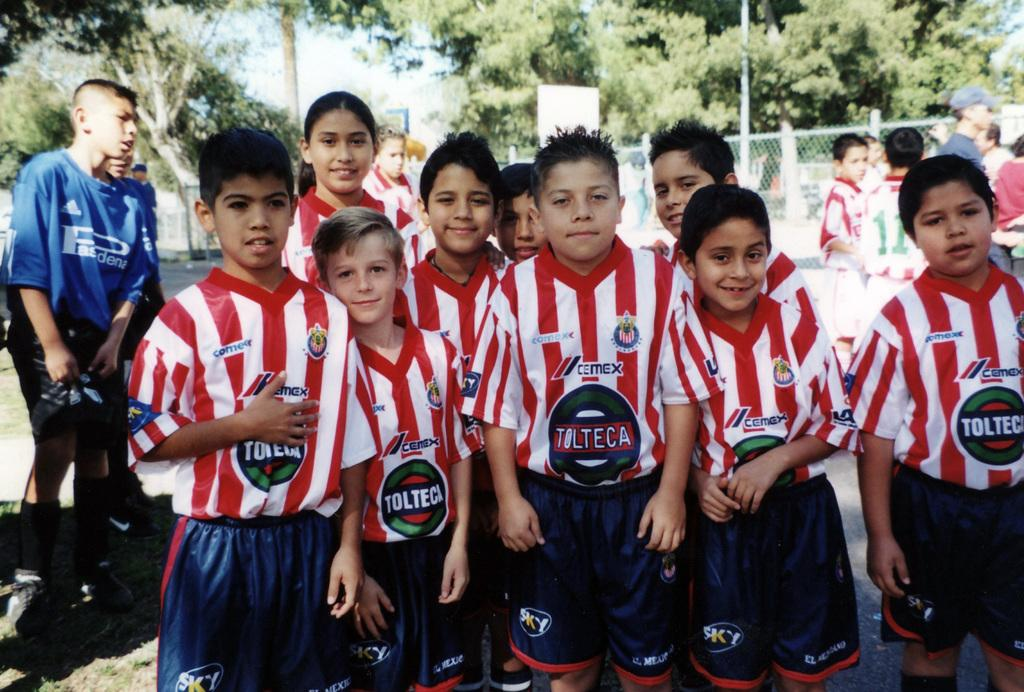Provide a one-sentence caption for the provided image. A young soccer team sponsored by Tolteca gather together outside. 